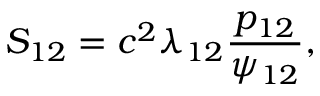Convert formula to latex. <formula><loc_0><loc_0><loc_500><loc_500>S _ { 1 2 } = c ^ { 2 } \lambda _ { 1 2 } \frac { p _ { 1 2 } } { \psi _ { 1 2 } } ,</formula> 